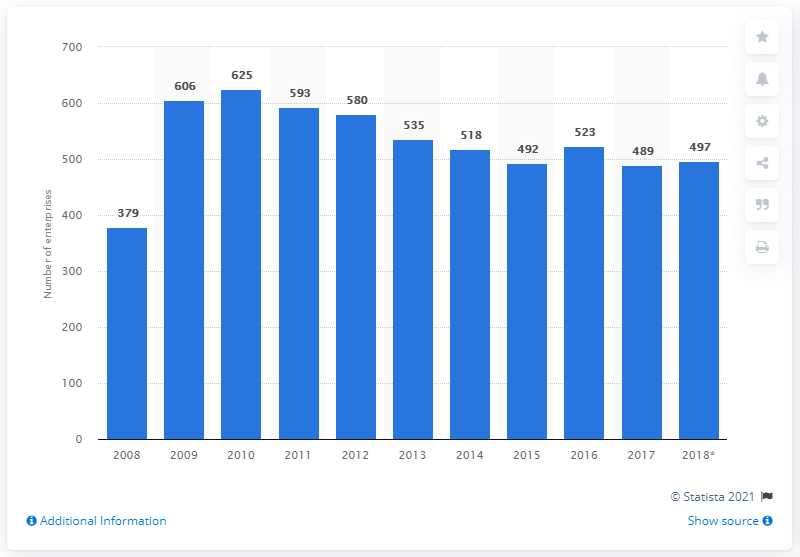List a handful of essential elements in this visual. In 2017, 489 enterprises manufactured furniture in Malta. 